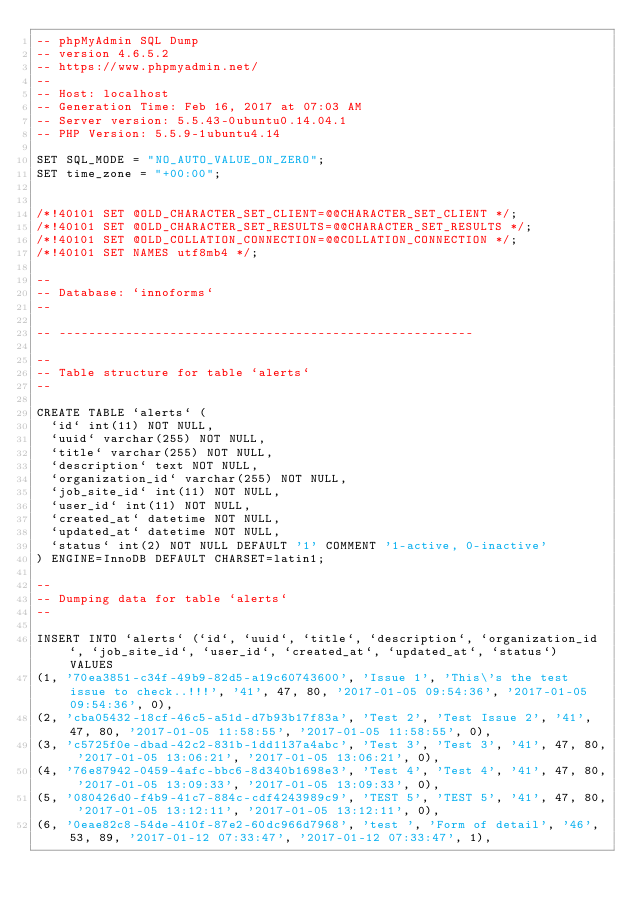Convert code to text. <code><loc_0><loc_0><loc_500><loc_500><_SQL_>-- phpMyAdmin SQL Dump
-- version 4.6.5.2
-- https://www.phpmyadmin.net/
--
-- Host: localhost
-- Generation Time: Feb 16, 2017 at 07:03 AM
-- Server version: 5.5.43-0ubuntu0.14.04.1
-- PHP Version: 5.5.9-1ubuntu4.14

SET SQL_MODE = "NO_AUTO_VALUE_ON_ZERO";
SET time_zone = "+00:00";


/*!40101 SET @OLD_CHARACTER_SET_CLIENT=@@CHARACTER_SET_CLIENT */;
/*!40101 SET @OLD_CHARACTER_SET_RESULTS=@@CHARACTER_SET_RESULTS */;
/*!40101 SET @OLD_COLLATION_CONNECTION=@@COLLATION_CONNECTION */;
/*!40101 SET NAMES utf8mb4 */;

--
-- Database: `innoforms`
--

-- --------------------------------------------------------

--
-- Table structure for table `alerts`
--

CREATE TABLE `alerts` (
  `id` int(11) NOT NULL,
  `uuid` varchar(255) NOT NULL,
  `title` varchar(255) NOT NULL,
  `description` text NOT NULL,
  `organization_id` varchar(255) NOT NULL,
  `job_site_id` int(11) NOT NULL,
  `user_id` int(11) NOT NULL,
  `created_at` datetime NOT NULL,
  `updated_at` datetime NOT NULL,
  `status` int(2) NOT NULL DEFAULT '1' COMMENT '1-active, 0-inactive'
) ENGINE=InnoDB DEFAULT CHARSET=latin1;

--
-- Dumping data for table `alerts`
--

INSERT INTO `alerts` (`id`, `uuid`, `title`, `description`, `organization_id`, `job_site_id`, `user_id`, `created_at`, `updated_at`, `status`) VALUES
(1, '70ea3851-c34f-49b9-82d5-a19c60743600', 'Issue 1', 'This\'s the test issue to check..!!!', '41', 47, 80, '2017-01-05 09:54:36', '2017-01-05 09:54:36', 0),
(2, 'cba05432-18cf-46c5-a51d-d7b93b17f83a', 'Test 2', 'Test Issue 2', '41', 47, 80, '2017-01-05 11:58:55', '2017-01-05 11:58:55', 0),
(3, 'c5725f0e-dbad-42c2-831b-1dd1137a4abc', 'Test 3', 'Test 3', '41', 47, 80, '2017-01-05 13:06:21', '2017-01-05 13:06:21', 0),
(4, '76e87942-0459-4afc-bbc6-8d340b1698e3', 'Test 4', 'Test 4', '41', 47, 80, '2017-01-05 13:09:33', '2017-01-05 13:09:33', 0),
(5, '080426d0-f4b9-41c7-884c-cdf4243989c9', 'TEST 5', 'TEST 5', '41', 47, 80, '2017-01-05 13:12:11', '2017-01-05 13:12:11', 0),
(6, '0eae82c8-54de-410f-87e2-60dc966d7968', 'test ', 'Form of detail', '46', 53, 89, '2017-01-12 07:33:47', '2017-01-12 07:33:47', 1),</code> 